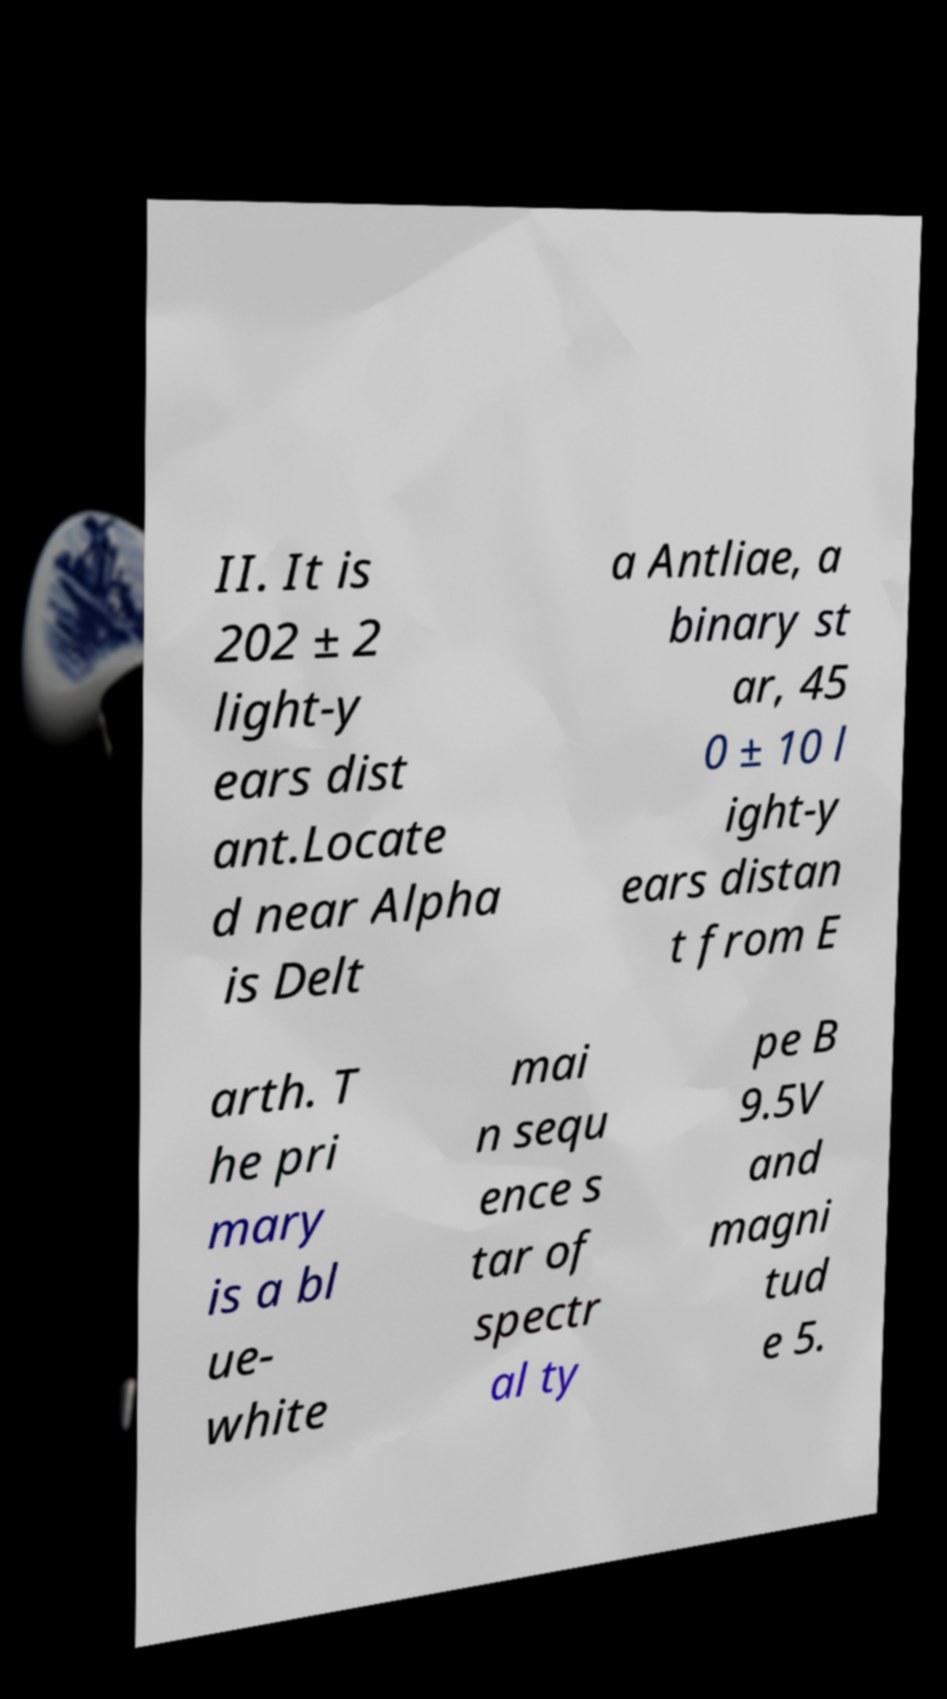There's text embedded in this image that I need extracted. Can you transcribe it verbatim? II. It is 202 ± 2 light-y ears dist ant.Locate d near Alpha is Delt a Antliae, a binary st ar, 45 0 ± 10 l ight-y ears distan t from E arth. T he pri mary is a bl ue- white mai n sequ ence s tar of spectr al ty pe B 9.5V and magni tud e 5. 